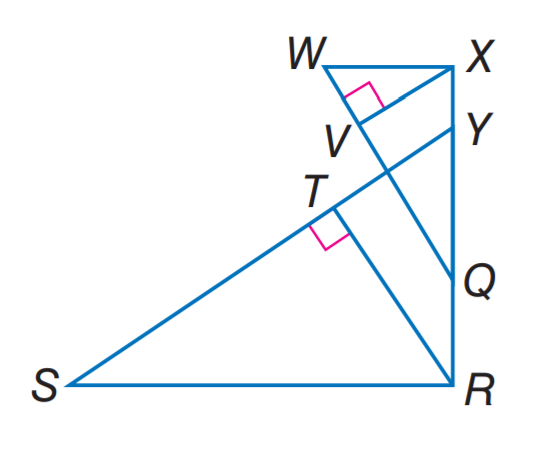Answer the mathemtical geometry problem and directly provide the correct option letter.
Question: If \triangle S R Y \sim \triangle W X Q, R T is an altitude of \triangle S R Y, X V is an altitude of \triangle W X Q, R T = 5, R Q = 4, Q Y = 6, and Y X = 2, find X V.
Choices: A: 2 B: 4 C: 5 D: 6 B 